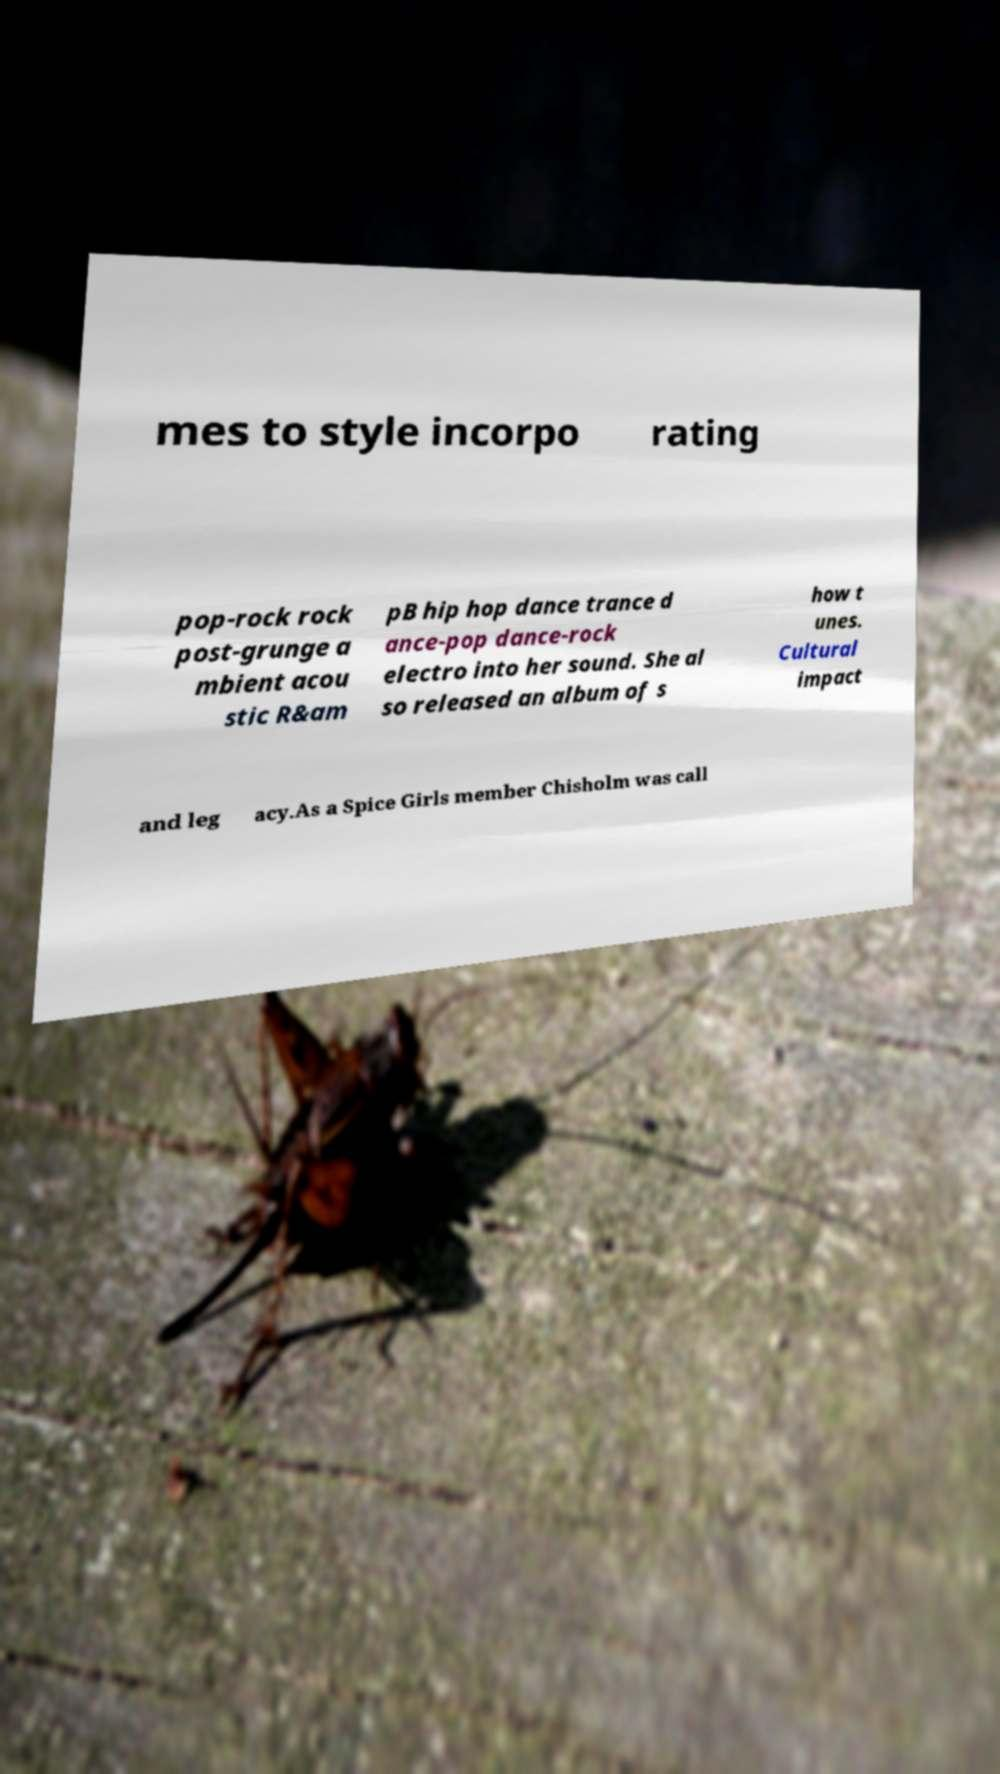Please identify and transcribe the text found in this image. mes to style incorpo rating pop-rock rock post-grunge a mbient acou stic R&am pB hip hop dance trance d ance-pop dance-rock electro into her sound. She al so released an album of s how t unes. Cultural impact and leg acy.As a Spice Girls member Chisholm was call 